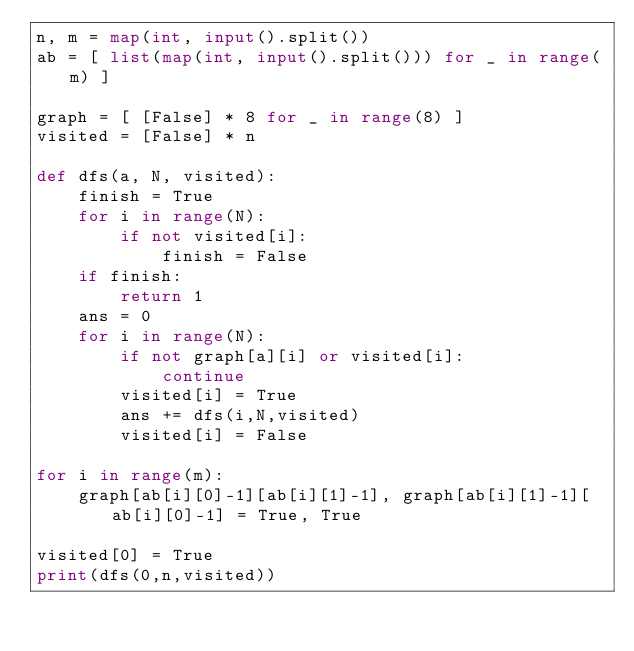<code> <loc_0><loc_0><loc_500><loc_500><_Python_>n, m = map(int, input().split())
ab = [ list(map(int, input().split())) for _ in range(m) ]

graph = [ [False] * 8 for _ in range(8) ]
visited = [False] * n

def dfs(a, N, visited):
    finish = True
    for i in range(N):
        if not visited[i]:
            finish = False
    if finish:
        return 1
    ans = 0
    for i in range(N):
        if not graph[a][i] or visited[i]:
            continue
        visited[i] = True
        ans += dfs(i,N,visited)
        visited[i] = False

for i in range(m):
    graph[ab[i][0]-1][ab[i][1]-1], graph[ab[i][1]-1][ab[i][0]-1] = True, True

visited[0] = True
print(dfs(0,n,visited))</code> 